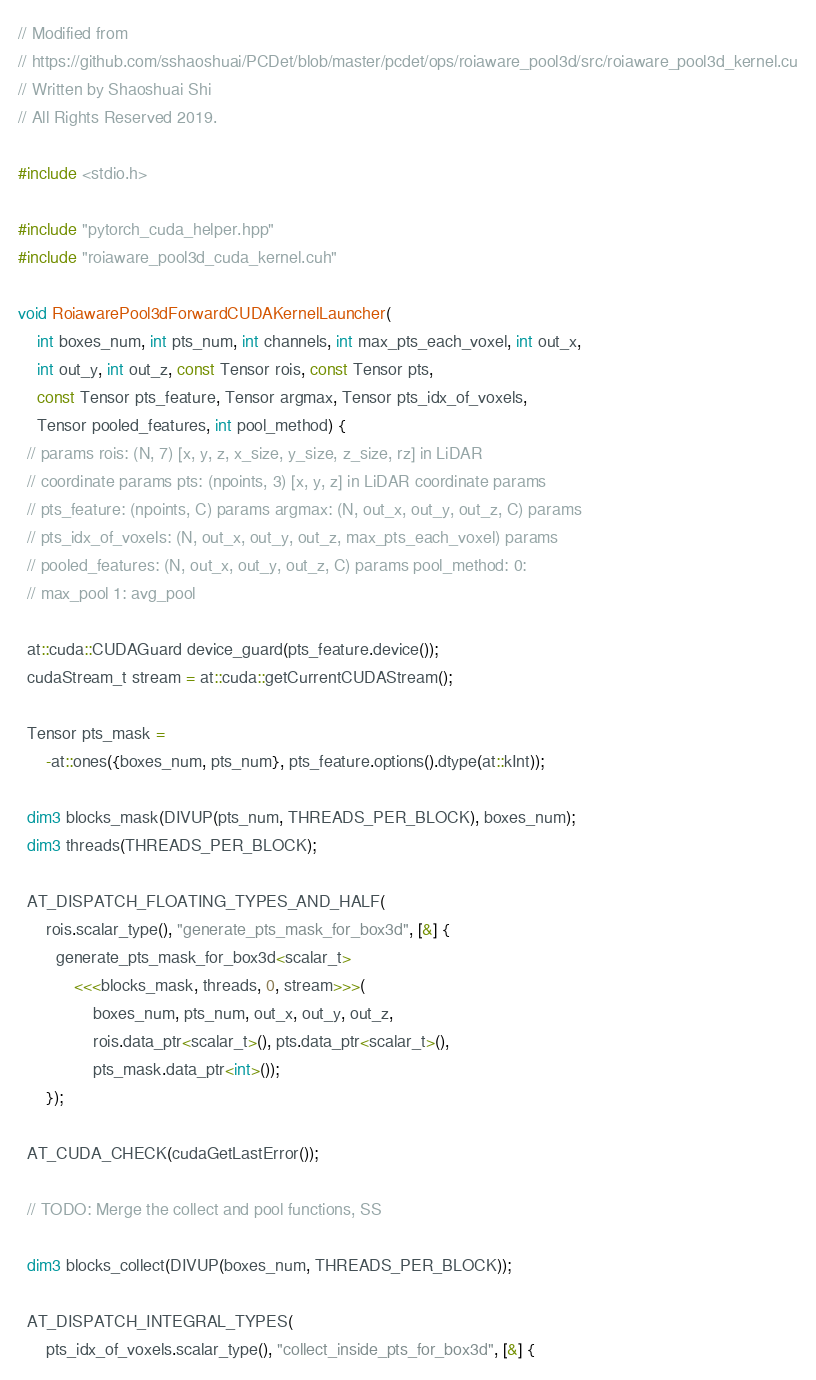<code> <loc_0><loc_0><loc_500><loc_500><_Cuda_>// Modified from
// https://github.com/sshaoshuai/PCDet/blob/master/pcdet/ops/roiaware_pool3d/src/roiaware_pool3d_kernel.cu
// Written by Shaoshuai Shi
// All Rights Reserved 2019.

#include <stdio.h>

#include "pytorch_cuda_helper.hpp"
#include "roiaware_pool3d_cuda_kernel.cuh"

void RoiawarePool3dForwardCUDAKernelLauncher(
    int boxes_num, int pts_num, int channels, int max_pts_each_voxel, int out_x,
    int out_y, int out_z, const Tensor rois, const Tensor pts,
    const Tensor pts_feature, Tensor argmax, Tensor pts_idx_of_voxels,
    Tensor pooled_features, int pool_method) {
  // params rois: (N, 7) [x, y, z, x_size, y_size, z_size, rz] in LiDAR
  // coordinate params pts: (npoints, 3) [x, y, z] in LiDAR coordinate params
  // pts_feature: (npoints, C) params argmax: (N, out_x, out_y, out_z, C) params
  // pts_idx_of_voxels: (N, out_x, out_y, out_z, max_pts_each_voxel) params
  // pooled_features: (N, out_x, out_y, out_z, C) params pool_method: 0:
  // max_pool 1: avg_pool

  at::cuda::CUDAGuard device_guard(pts_feature.device());
  cudaStream_t stream = at::cuda::getCurrentCUDAStream();

  Tensor pts_mask =
      -at::ones({boxes_num, pts_num}, pts_feature.options().dtype(at::kInt));

  dim3 blocks_mask(DIVUP(pts_num, THREADS_PER_BLOCK), boxes_num);
  dim3 threads(THREADS_PER_BLOCK);

  AT_DISPATCH_FLOATING_TYPES_AND_HALF(
      rois.scalar_type(), "generate_pts_mask_for_box3d", [&] {
        generate_pts_mask_for_box3d<scalar_t>
            <<<blocks_mask, threads, 0, stream>>>(
                boxes_num, pts_num, out_x, out_y, out_z,
                rois.data_ptr<scalar_t>(), pts.data_ptr<scalar_t>(),
                pts_mask.data_ptr<int>());
      });

  AT_CUDA_CHECK(cudaGetLastError());

  // TODO: Merge the collect and pool functions, SS

  dim3 blocks_collect(DIVUP(boxes_num, THREADS_PER_BLOCK));

  AT_DISPATCH_INTEGRAL_TYPES(
      pts_idx_of_voxels.scalar_type(), "collect_inside_pts_for_box3d", [&] {</code> 